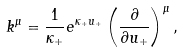<formula> <loc_0><loc_0><loc_500><loc_500>k ^ { \mu } = \frac { 1 } { \kappa _ { + } } e ^ { \kappa _ { + } u _ { + } } \left ( \frac { \partial } { \partial u _ { + } } \right ) ^ { \mu } ,</formula> 